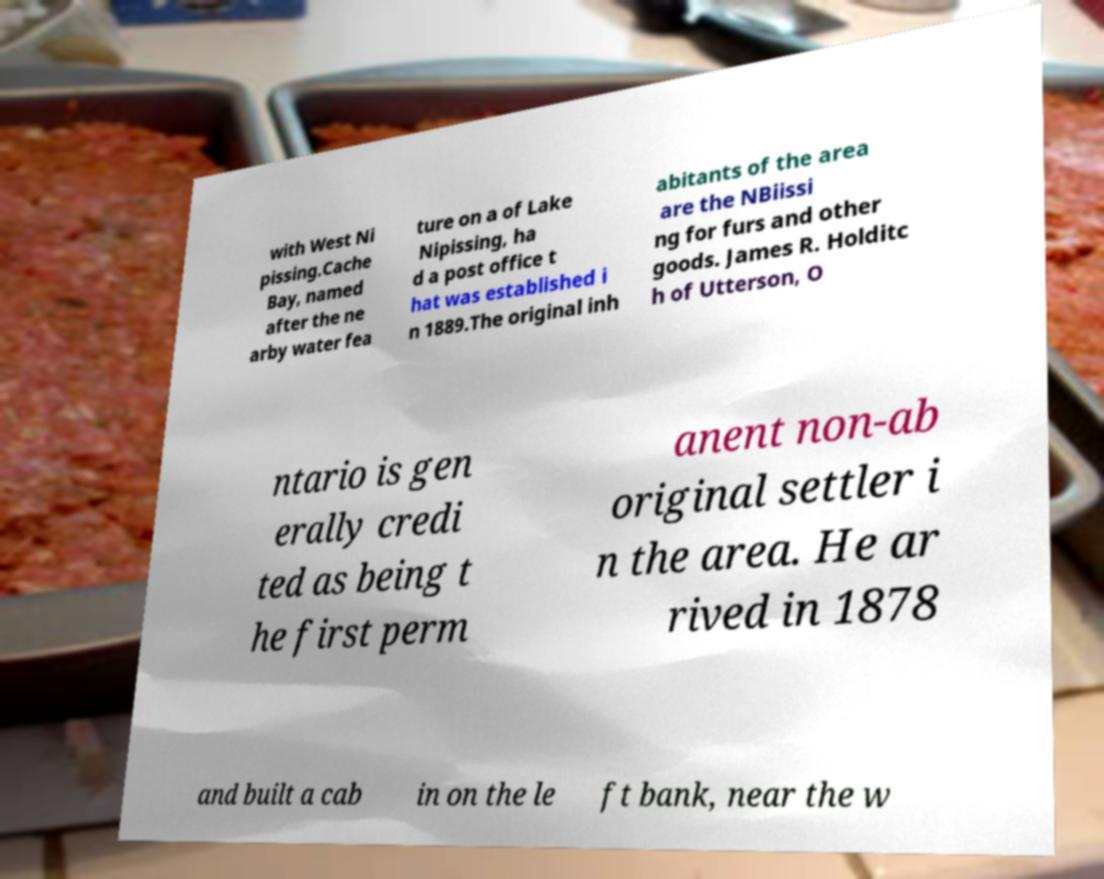Please read and relay the text visible in this image. What does it say? with West Ni pissing.Cache Bay, named after the ne arby water fea ture on a of Lake Nipissing, ha d a post office t hat was established i n 1889.The original inh abitants of the area are the NBiissi ng for furs and other goods. James R. Holditc h of Utterson, O ntario is gen erally credi ted as being t he first perm anent non-ab original settler i n the area. He ar rived in 1878 and built a cab in on the le ft bank, near the w 